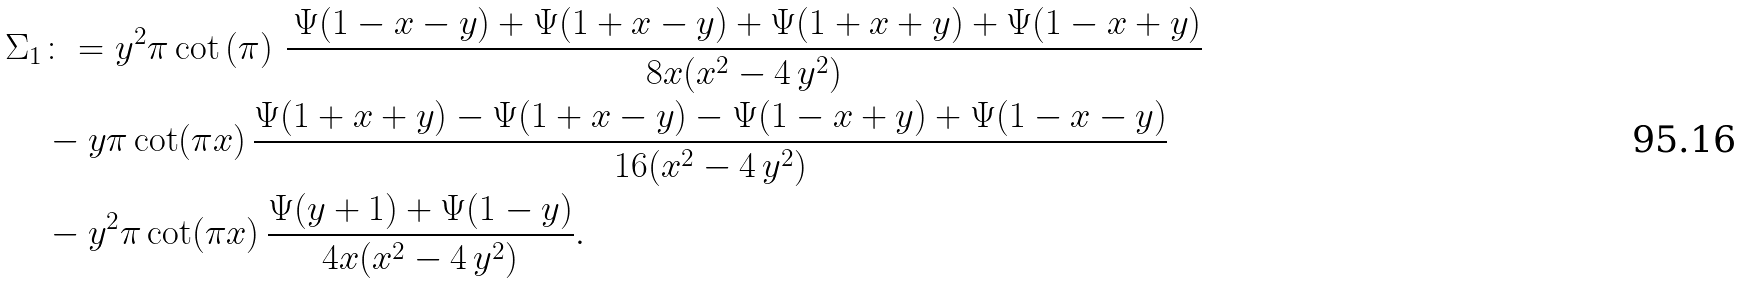<formula> <loc_0><loc_0><loc_500><loc_500>\Sigma _ { 1 } & \colon = { y } ^ { 2 } \pi \cot \left ( \pi \right ) \, { \frac { \, \Psi ( 1 - x - y ) + \Psi ( 1 + x - y ) + \Psi ( 1 + x + y ) + \Psi ( 1 - x + y ) } { 8 x ( { x } ^ { 2 } - 4 \, { y } ^ { 2 } ) } } \\ & - y \pi \cot ( \pi x ) \, { \frac { \Psi ( 1 + x + y ) - \Psi ( 1 + x - y ) - \Psi ( 1 - x + y ) + \Psi ( 1 - x - y ) } { 1 6 ( { x } ^ { 2 } - 4 \, { y } ^ { 2 } ) } } \\ & - { y } ^ { 2 } \pi \cot ( \pi x ) \, { \frac { \Psi ( y + 1 ) + \Psi ( 1 - y ) } { 4 x ( { x } ^ { 2 } - 4 \, { y } ^ { 2 } ) } } .</formula> 